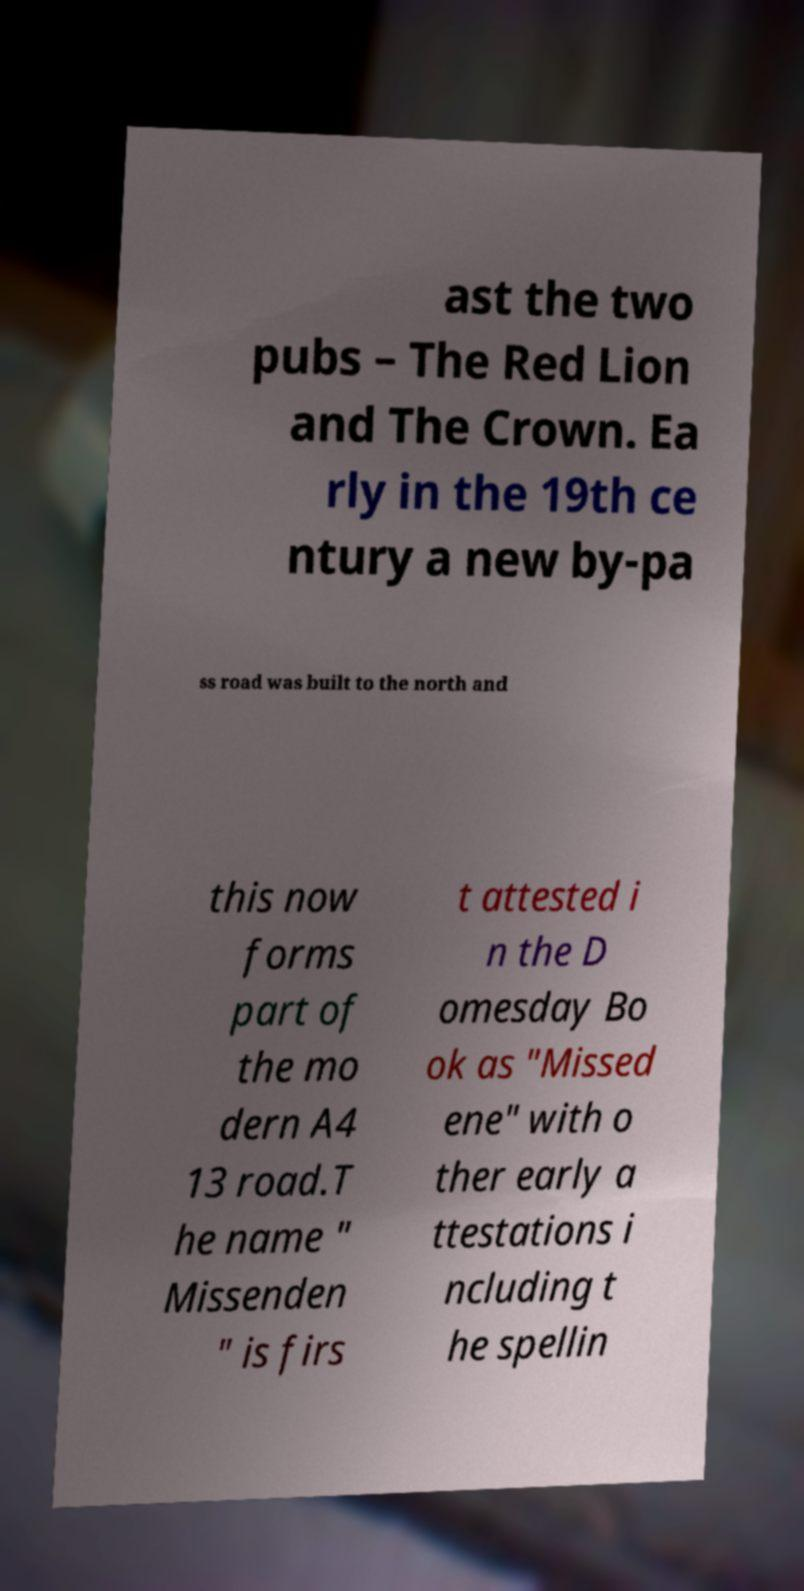Can you read and provide the text displayed in the image?This photo seems to have some interesting text. Can you extract and type it out for me? ast the two pubs – The Red Lion and The Crown. Ea rly in the 19th ce ntury a new by-pa ss road was built to the north and this now forms part of the mo dern A4 13 road.T he name " Missenden " is firs t attested i n the D omesday Bo ok as "Missed ene" with o ther early a ttestations i ncluding t he spellin 